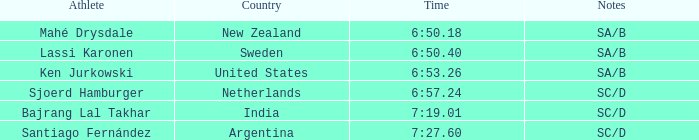Would you be able to parse every entry in this table? {'header': ['Athlete', 'Country', 'Time', 'Notes'], 'rows': [['Mahé Drysdale', 'New Zealand', '6:50.18', 'SA/B'], ['Lassi Karonen', 'Sweden', '6:50.40', 'SA/B'], ['Ken Jurkowski', 'United States', '6:53.26', 'SA/B'], ['Sjoerd Hamburger', 'Netherlands', '6:57.24', 'SC/D'], ['Bajrang Lal Takhar', 'India', '7:19.01', 'SC/D'], ['Santiago Fernández', 'Argentina', '7:27.60', 'SC/D']]} What is documented in the notes about the athlete, lassi karonen? SA/B. 